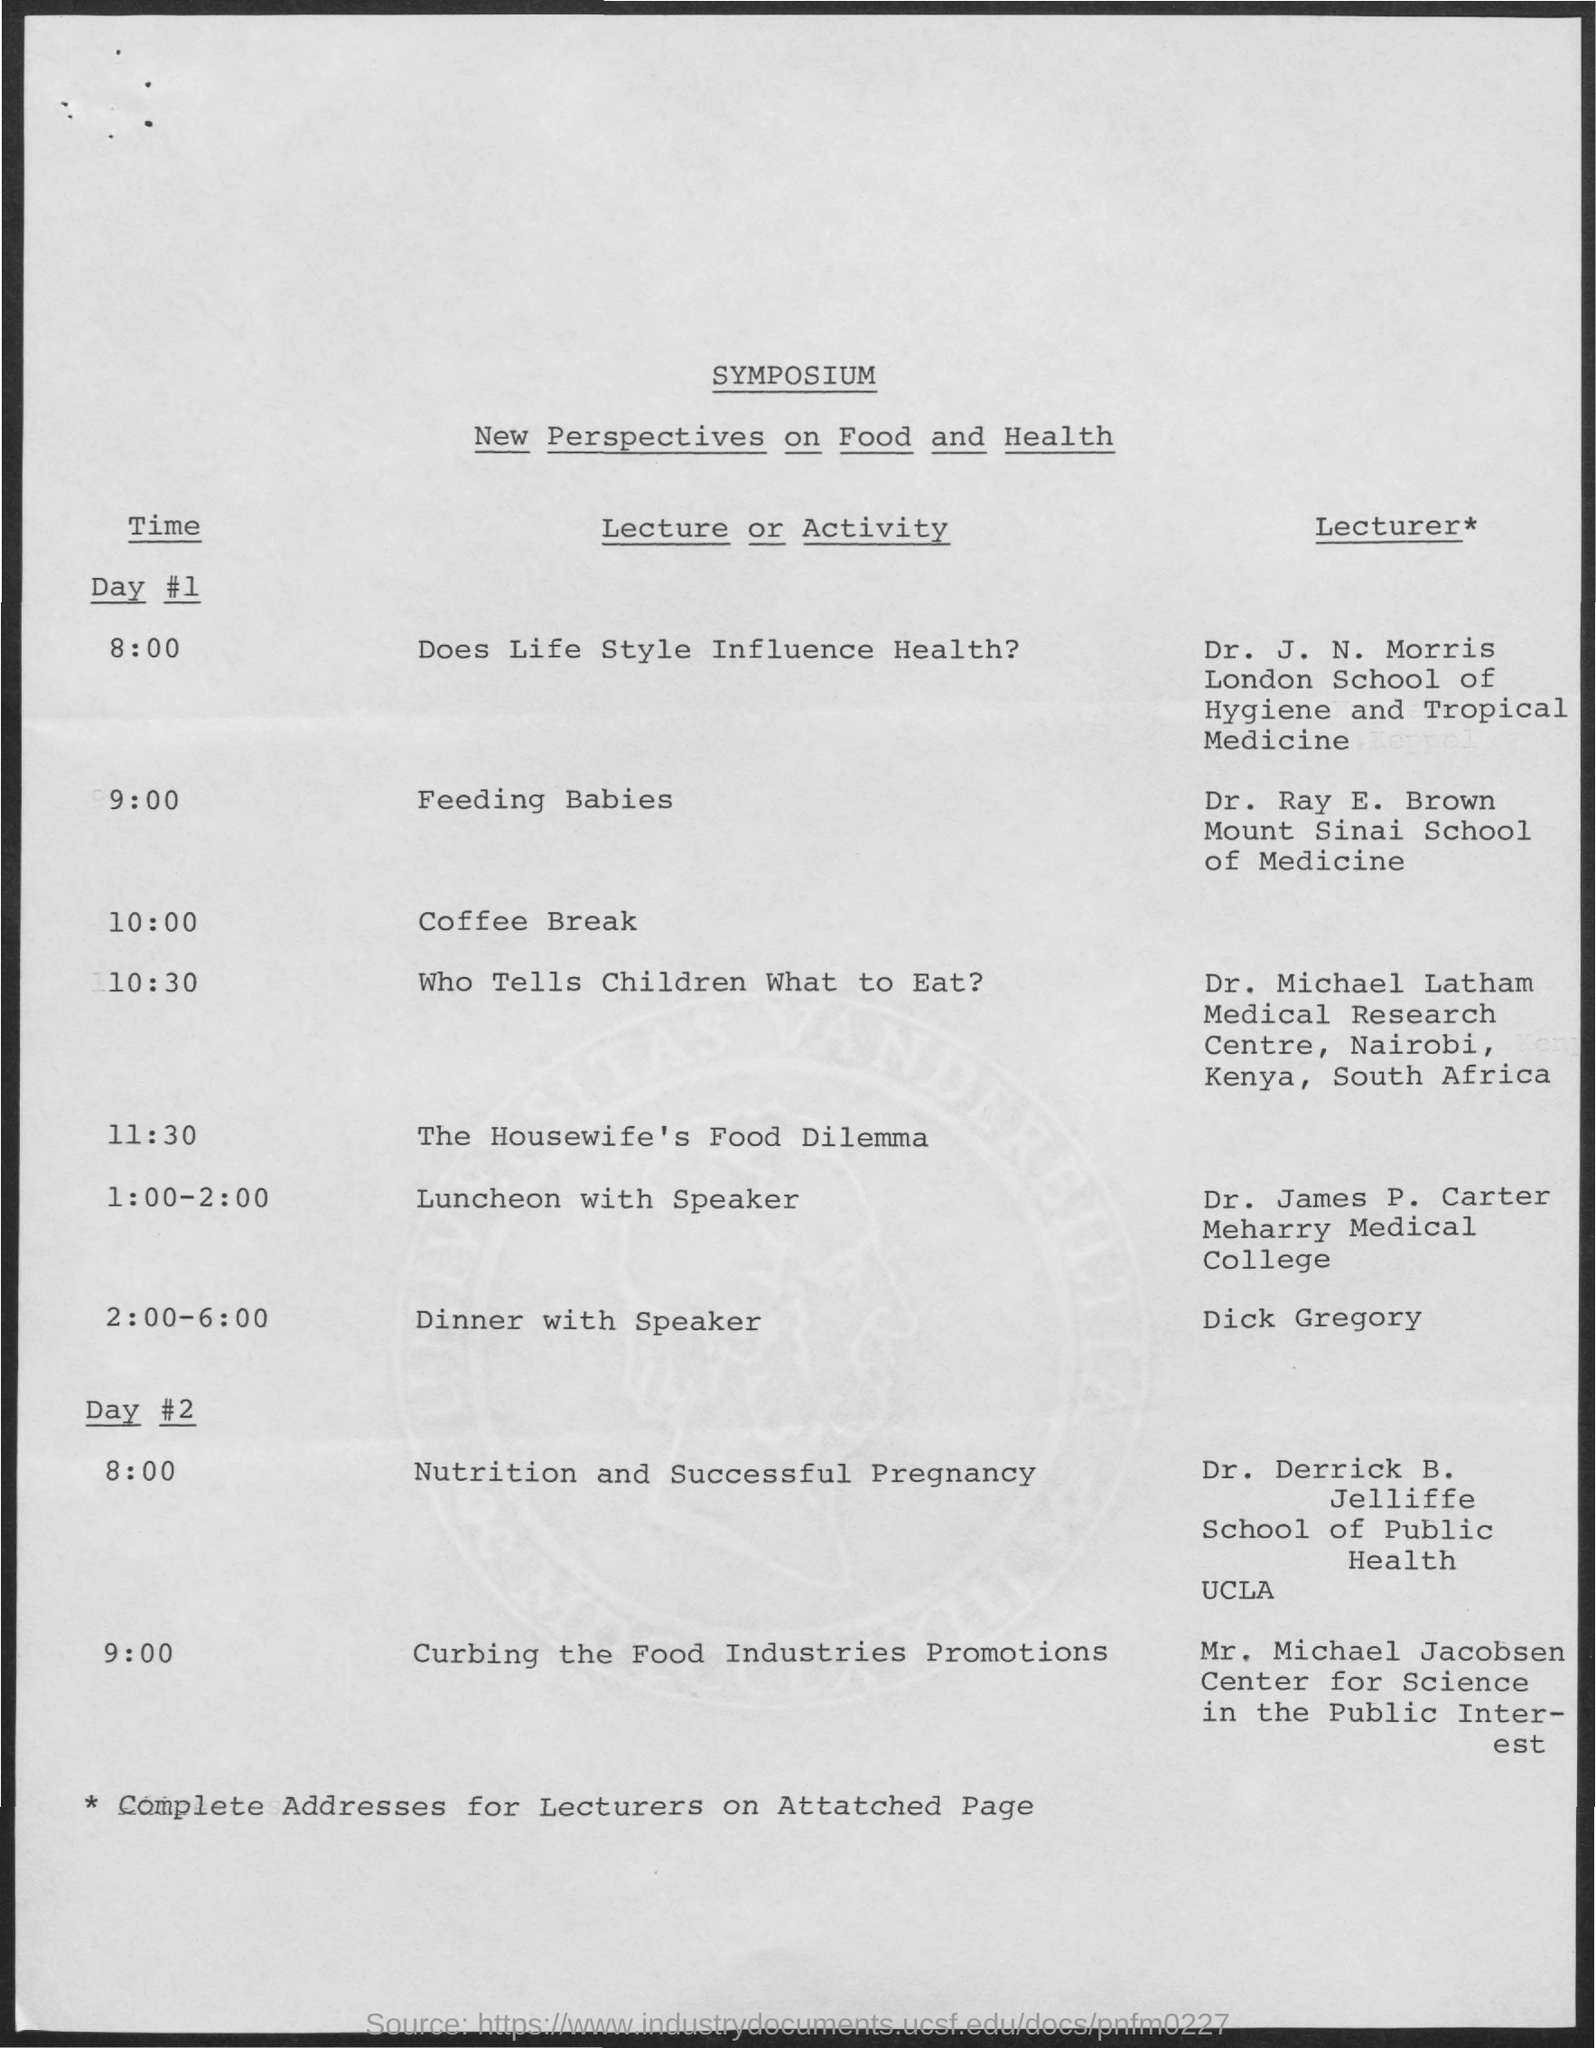What is the activity at the time of 8:00 on day #1 ?
Provide a short and direct response. Does life style influence health ?. What is the name of the activity at the time of 9:00 on day #1 ?
Offer a very short reply. Feeding babies. What is the activity at the time of 10:00 on day #1?
Offer a terse response. Coffee Break. What is the name of the activity at the time of 10:30 on day #1?
Ensure brevity in your answer.  Who Tells Children What to Eat?. What is the name of the activity at the time of 11:30 on day #1?
Make the answer very short. The Housewife's Food Dilemma. What is the name of the activity at the time of 1:00- 2:00 on day#1?
Ensure brevity in your answer.  Luncheon with speaker. What is the activity at the time of 2:00 - 6:00 on day #1?
Provide a succinct answer. Dinner with Speaker. What is the name of the activity at the time of 8:00 on day #2?
Ensure brevity in your answer.  Nutrition and successful pregnancy. What is the name of the activity at the time of 9:00 on day #2?
Your answer should be compact. Curbing the Food Industries Promotions. 